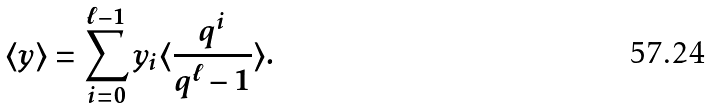<formula> <loc_0><loc_0><loc_500><loc_500>\langle y \rangle = \sum _ { i = 0 } ^ { \ell - 1 } y _ { i } \langle \frac { q ^ { i } } { q ^ { \ell } - 1 } \rangle .</formula> 